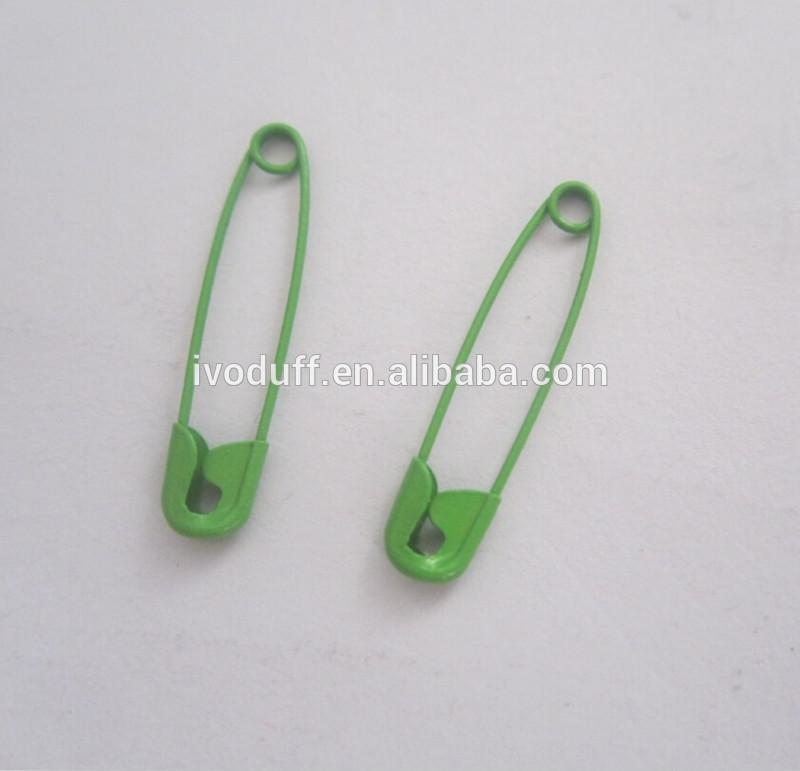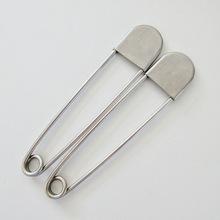The first image is the image on the left, the second image is the image on the right. Evaluate the accuracy of this statement regarding the images: "In at least one image the clip is not silver at all.". Is it true? Answer yes or no. Yes. 